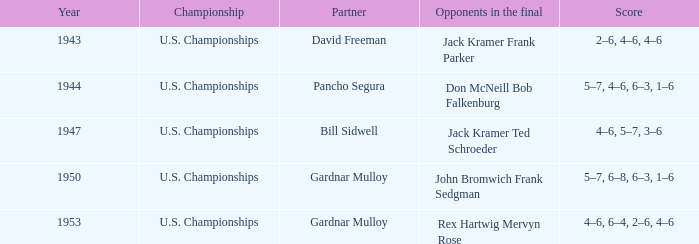In the final of john bromwich and frank sedgman, who are the opponents of the partner? Gardnar Mulloy. Could you parse the entire table as a dict? {'header': ['Year', 'Championship', 'Partner', 'Opponents in the final', 'Score'], 'rows': [['1943', 'U.S. Championships', 'David Freeman', 'Jack Kramer Frank Parker', '2–6, 4–6, 4–6'], ['1944', 'U.S. Championships', 'Pancho Segura', 'Don McNeill Bob Falkenburg', '5–7, 4–6, 6–3, 1–6'], ['1947', 'U.S. Championships', 'Bill Sidwell', 'Jack Kramer Ted Schroeder', '4–6, 5–7, 3–6'], ['1950', 'U.S. Championships', 'Gardnar Mulloy', 'John Bromwich Frank Sedgman', '5–7, 6–8, 6–3, 1–6'], ['1953', 'U.S. Championships', 'Gardnar Mulloy', 'Rex Hartwig Mervyn Rose', '4–6, 6–4, 2–6, 4–6']]} 